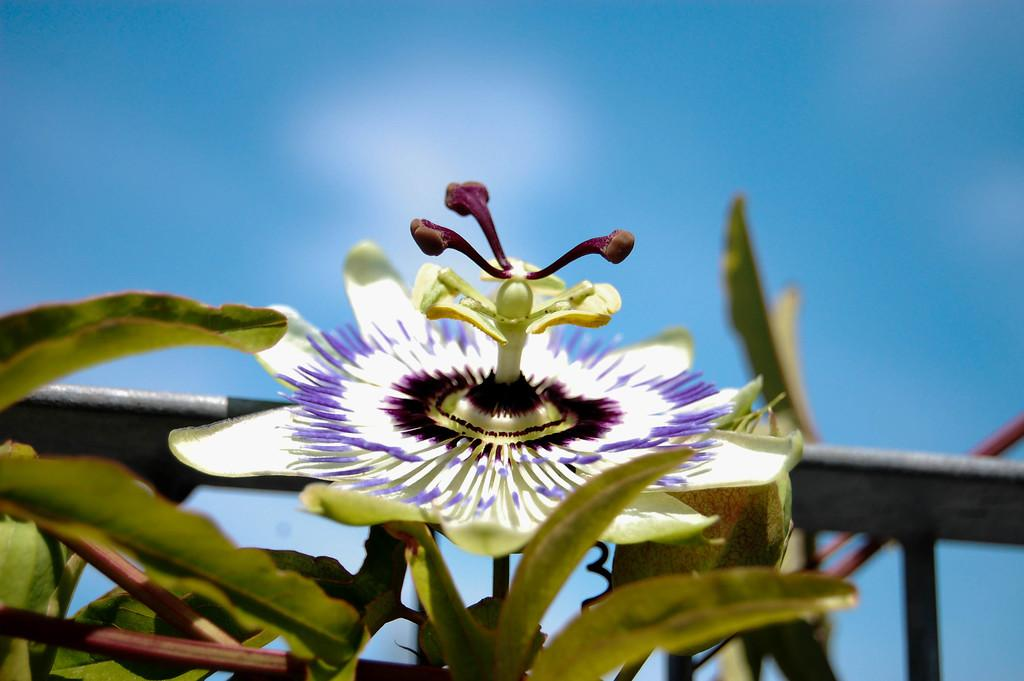What type of plant is in the image? There is a plant in the image, and it has a flower. What can be seen in the background of the image? There is a black railing in the background of the image. What is visible at the top of the image? The sky is visible at the top of the image. What type of tin is being used to hold the plant in the image? There is no tin present in the image; the plant is not being held in a tin container. 